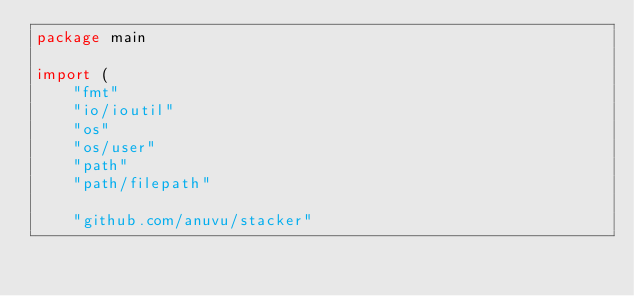<code> <loc_0><loc_0><loc_500><loc_500><_Go_>package main

import (
	"fmt"
	"io/ioutil"
	"os"
	"os/user"
	"path"
	"path/filepath"

	"github.com/anuvu/stacker"</code> 